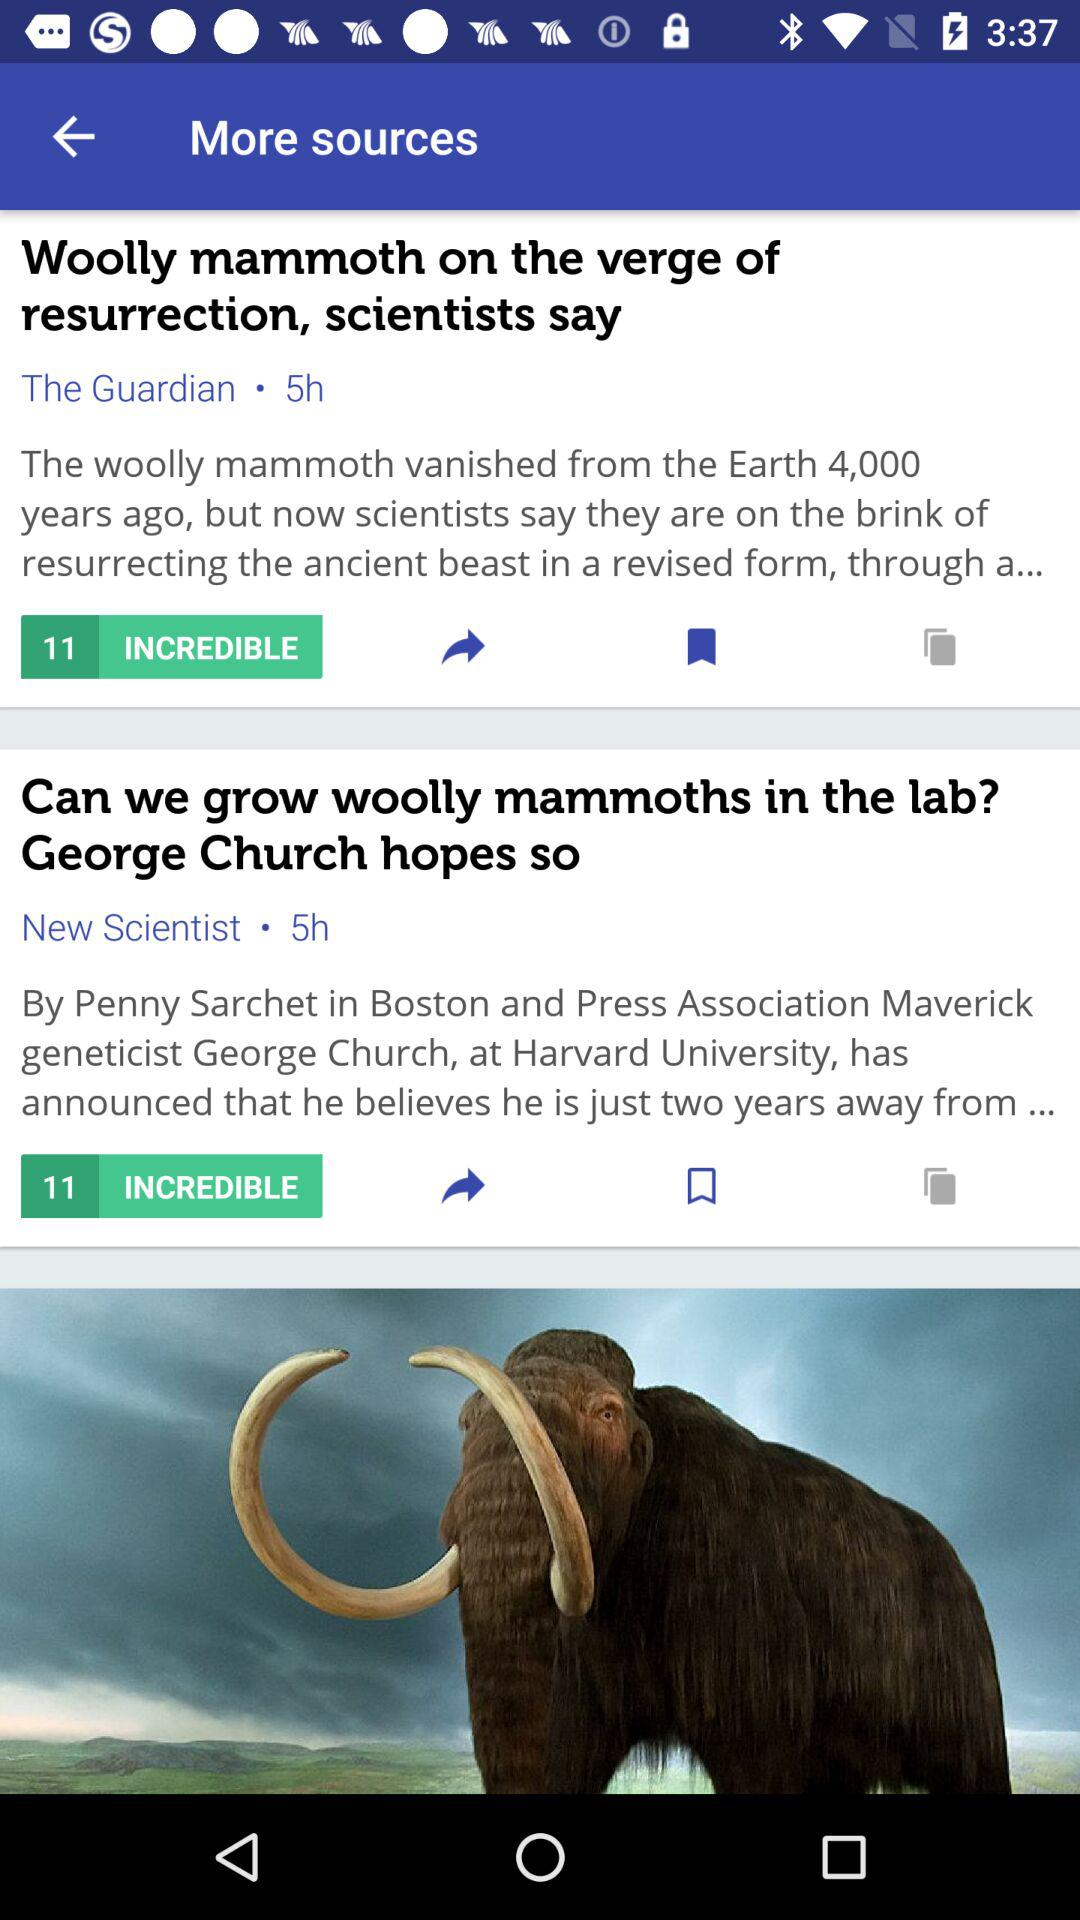How many sources are there?
Answer the question using a single word or phrase. 2 